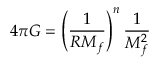<formula> <loc_0><loc_0><loc_500><loc_500>4 \pi G = \left ( \frac { 1 } { R M _ { f } } \right ) ^ { n } \frac { 1 } { M _ { f } ^ { 2 } }</formula> 